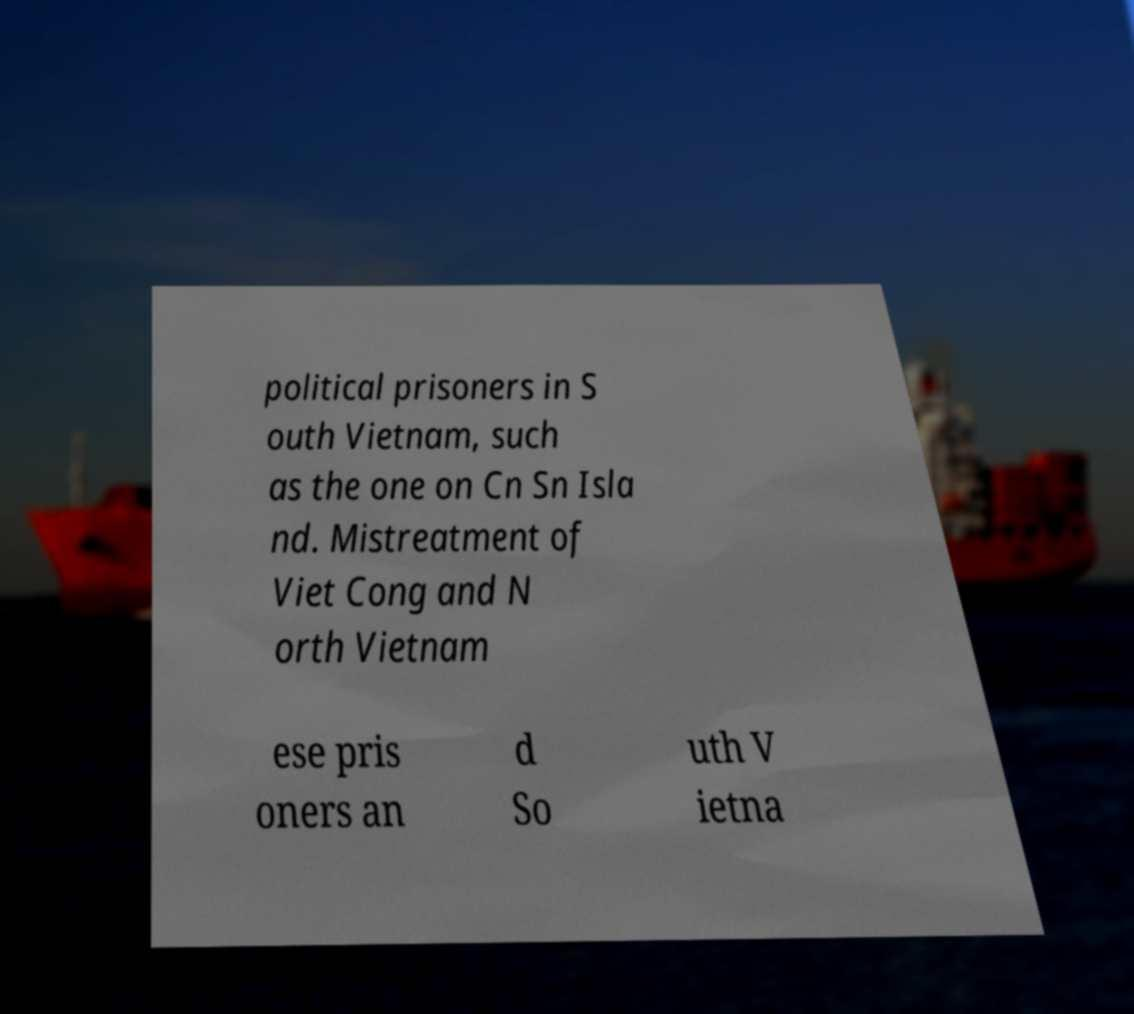I need the written content from this picture converted into text. Can you do that? political prisoners in S outh Vietnam, such as the one on Cn Sn Isla nd. Mistreatment of Viet Cong and N orth Vietnam ese pris oners an d So uth V ietna 